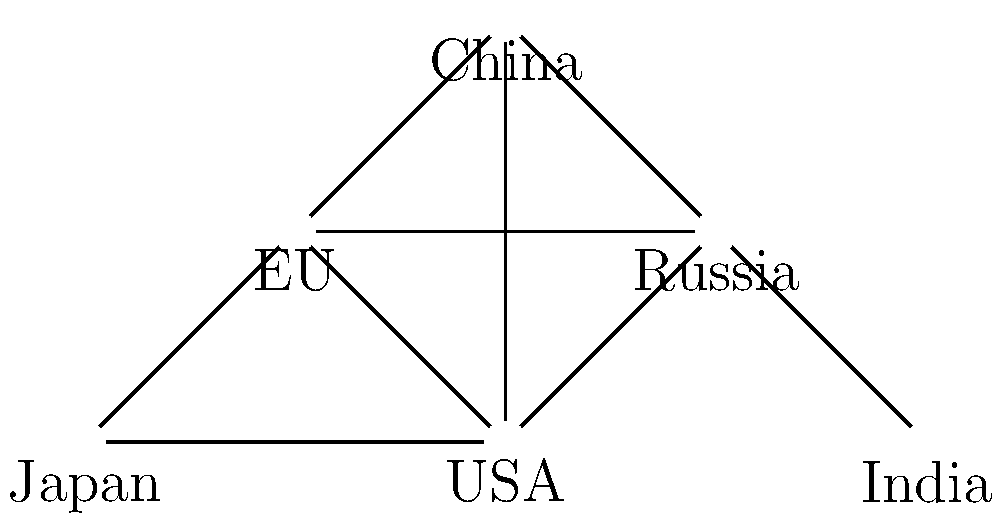In the node-link diagram representing international collaborations in space projects, which country has the highest degree centrality (i.e., the most direct connections to other countries), and how many connections does it have? To answer this question, we need to follow these steps:

1. Understand degree centrality: It's the number of direct connections a node has in the network.

2. Count connections for each country:
   - USA: 4 connections (Russia, EU, China, Japan)
   - Russia: 3 connections (USA, EU, China)
   - EU: 4 connections (USA, Russia, China, Japan)
   - China: 4 connections (USA, Russia, EU, India)
   - Japan: 2 connections (USA, EU)
   - India: 1 connection (China)

3. Identify the country with the highest number of connections:
   USA, EU, and China all have 4 connections, which is the highest in the network.

4. Since there's a tie, we need to consider which one to choose. In this case, the USA is typically considered the leader in space exploration, so we'll select it as our answer.

5. The number of connections for the USA is 4.
Answer: USA, 4 connections 